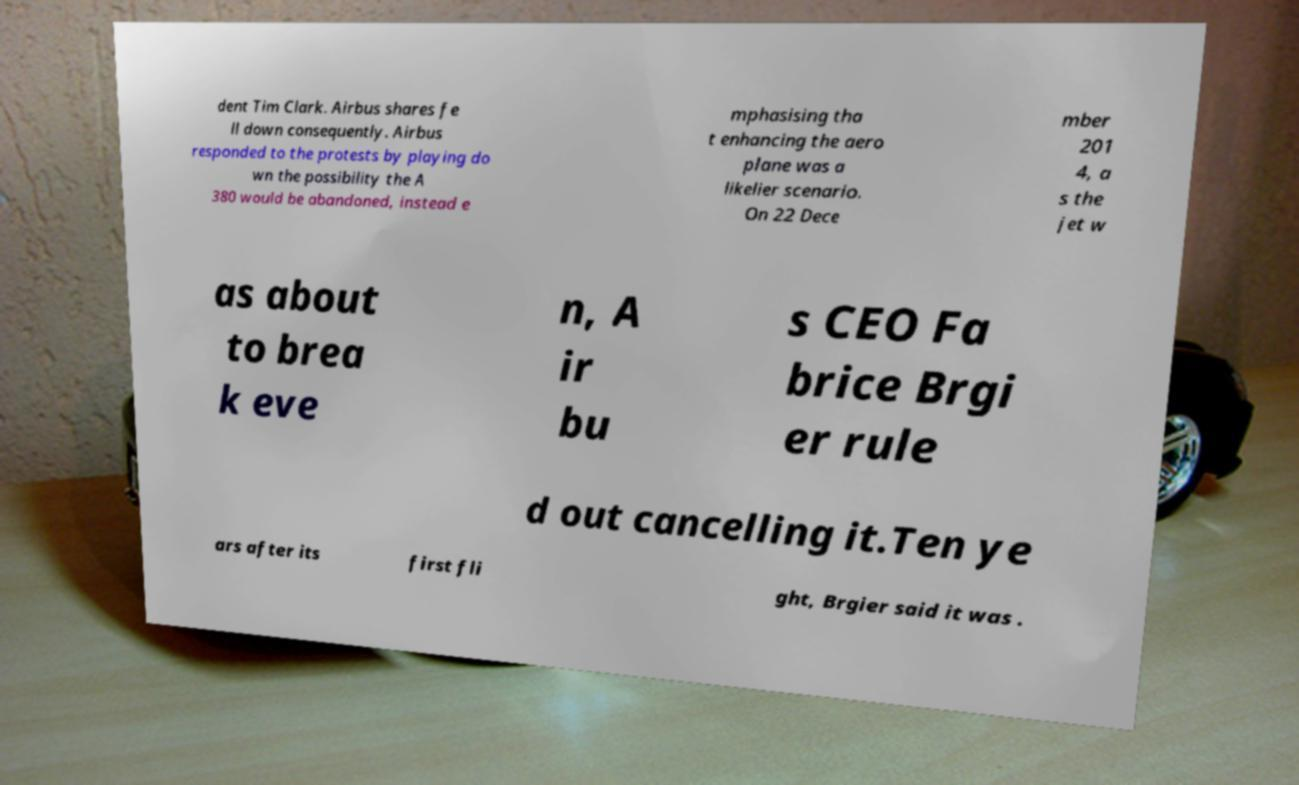Can you accurately transcribe the text from the provided image for me? dent Tim Clark. Airbus shares fe ll down consequently. Airbus responded to the protests by playing do wn the possibility the A 380 would be abandoned, instead e mphasising tha t enhancing the aero plane was a likelier scenario. On 22 Dece mber 201 4, a s the jet w as about to brea k eve n, A ir bu s CEO Fa brice Brgi er rule d out cancelling it.Ten ye ars after its first fli ght, Brgier said it was . 